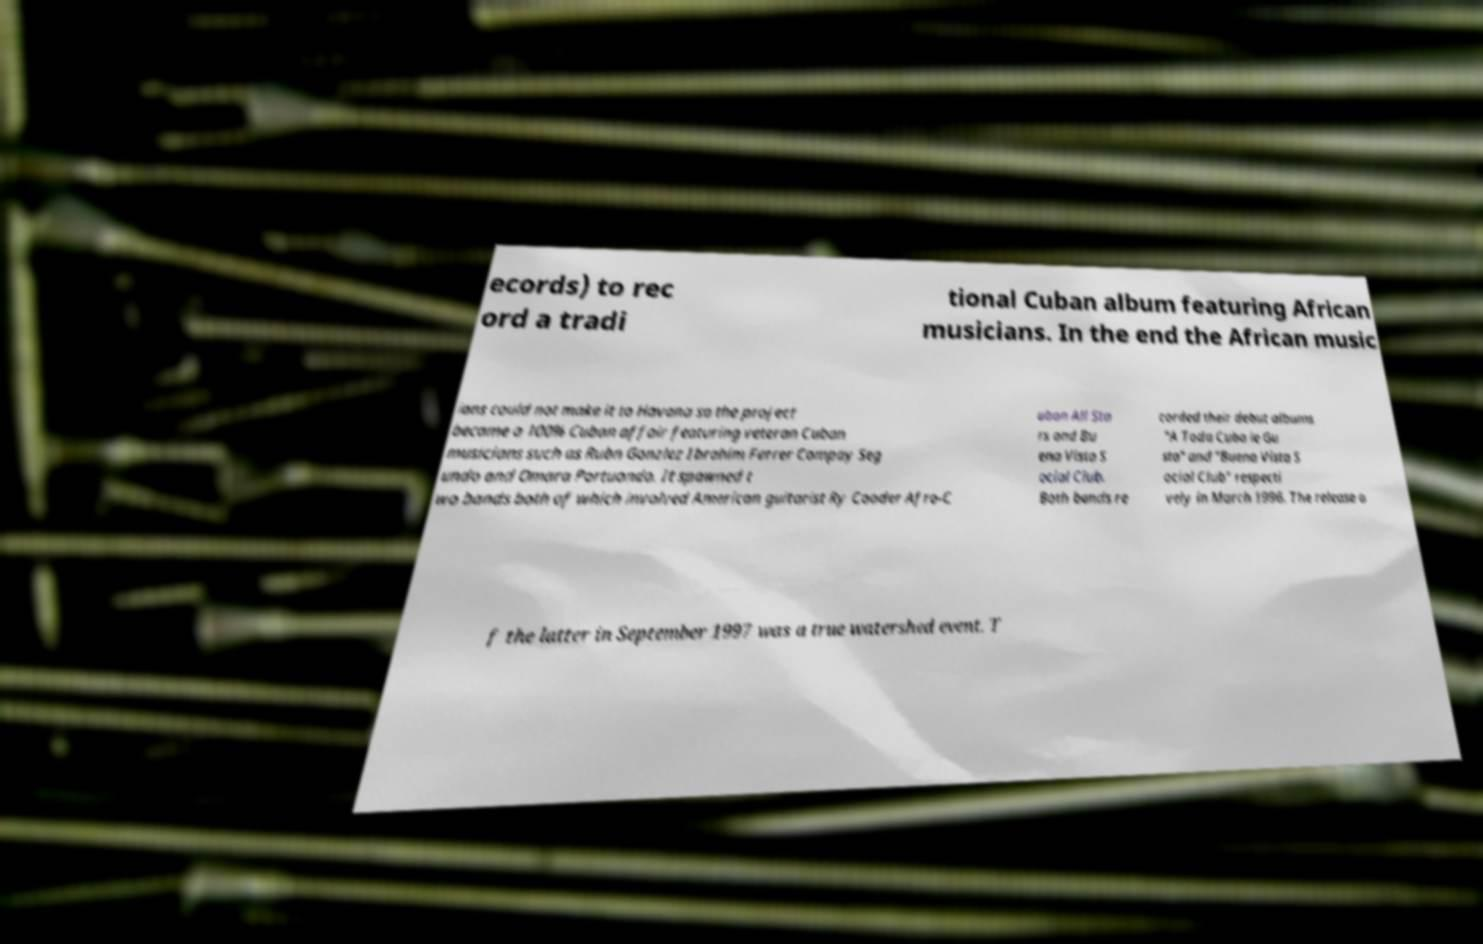Please read and relay the text visible in this image. What does it say? ecords) to rec ord a tradi tional Cuban album featuring African musicians. In the end the African music ians could not make it to Havana so the project became a 100% Cuban affair featuring veteran Cuban musicians such as Rubn Gonzlez Ibrahim Ferrer Compay Seg undo and Omara Portuondo. It spawned t wo bands both of which involved American guitarist Ry Cooder Afro-C uban All Sta rs and Bu ena Vista S ocial Club. Both bands re corded their debut albums "A Toda Cuba le Gu sta" and "Buena Vista S ocial Club" respecti vely in March 1996. The release o f the latter in September 1997 was a true watershed event. T 